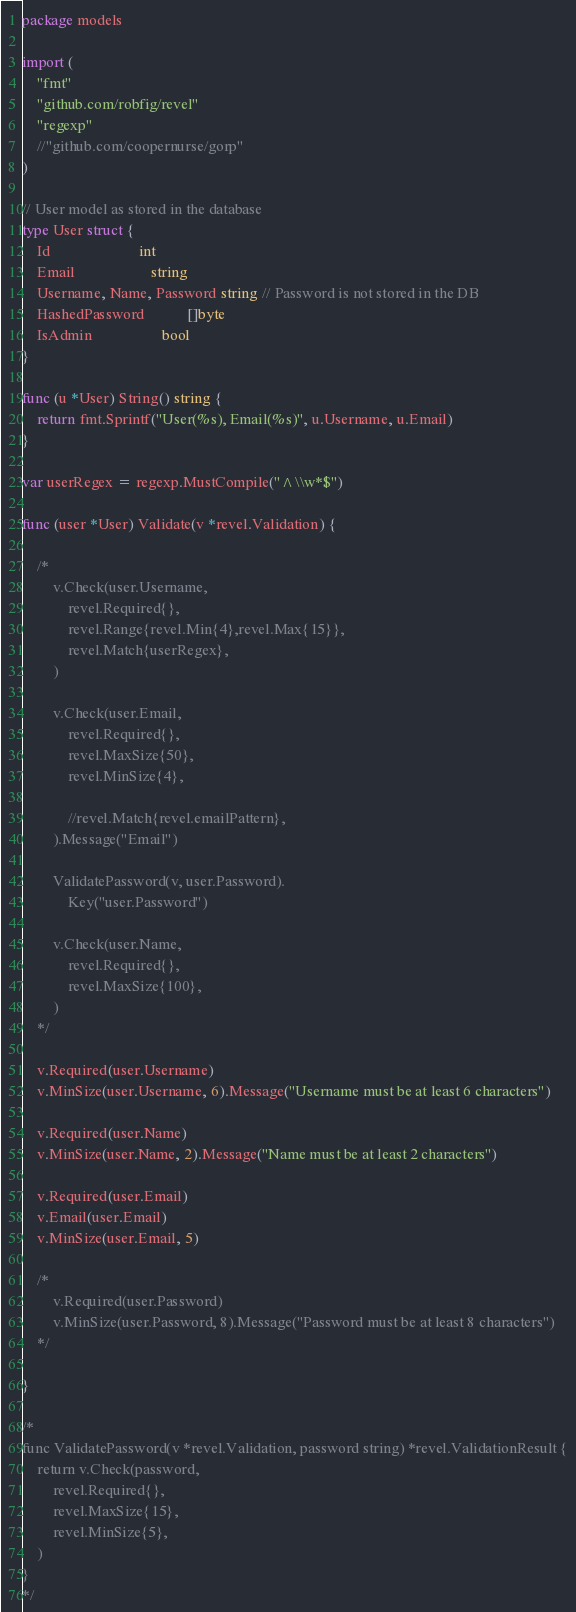Convert code to text. <code><loc_0><loc_0><loc_500><loc_500><_Go_>package models

import (
	"fmt"
	"github.com/robfig/revel"
	"regexp"
	//"github.com/coopernurse/gorp"
)

// User model as stored in the database
type User struct {
	Id                       int
	Email                    string
	Username, Name, Password string // Password is not stored in the DB
	HashedPassword           []byte
	IsAdmin                  bool
}

func (u *User) String() string {
	return fmt.Sprintf("User(%s), Email(%s)", u.Username, u.Email)
}

var userRegex = regexp.MustCompile("^\\w*$")

func (user *User) Validate(v *revel.Validation) {

	/*
		v.Check(user.Username,
			revel.Required{},
			revel.Range{revel.Min{4},revel.Max{15}},
			revel.Match{userRegex},
		)

		v.Check(user.Email,
			revel.Required{},
			revel.MaxSize{50},
			revel.MinSize{4},

			//revel.Match{revel.emailPattern},
		).Message("Email")

		ValidatePassword(v, user.Password).
			Key("user.Password")

		v.Check(user.Name,
			revel.Required{},
			revel.MaxSize{100},
		)
	*/

	v.Required(user.Username)
	v.MinSize(user.Username, 6).Message("Username must be at least 6 characters")

	v.Required(user.Name)
	v.MinSize(user.Name, 2).Message("Name must be at least 2 characters")

	v.Required(user.Email)
	v.Email(user.Email)
	v.MinSize(user.Email, 5)

	/*
		v.Required(user.Password)
		v.MinSize(user.Password, 8).Message("Password must be at least 8 characters")
	*/

}

/*
func ValidatePassword(v *revel.Validation, password string) *revel.ValidationResult {
	return v.Check(password,
		revel.Required{},
		revel.MaxSize{15},
		revel.MinSize{5},
	)
}
*/
</code> 